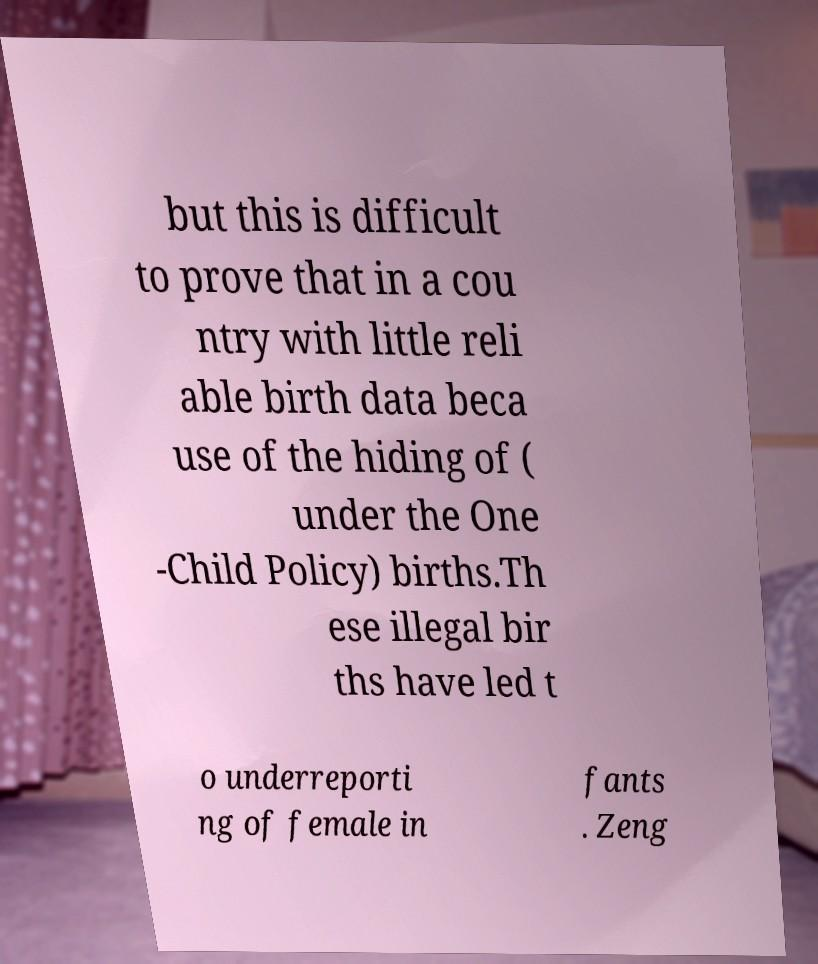I need the written content from this picture converted into text. Can you do that? but this is difficult to prove that in a cou ntry with little reli able birth data beca use of the hiding of ( under the One -Child Policy) births.Th ese illegal bir ths have led t o underreporti ng of female in fants . Zeng 